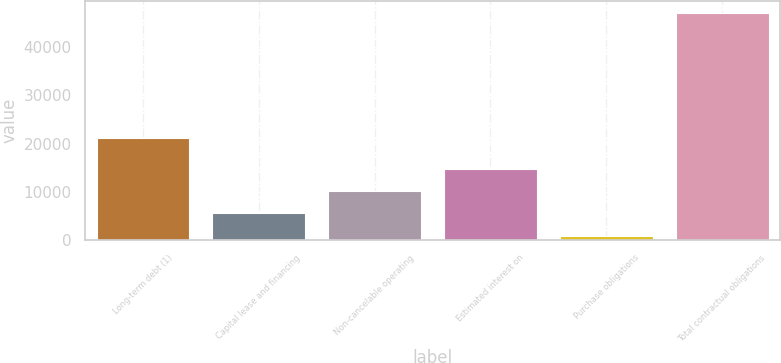<chart> <loc_0><loc_0><loc_500><loc_500><bar_chart><fcel>Long-term debt (1)<fcel>Capital lease and financing<fcel>Non-cancelable operating<fcel>Estimated interest on<fcel>Purchase obligations<fcel>Total contractual obligations<nl><fcel>21259<fcel>5544.6<fcel>10164.2<fcel>14783.8<fcel>925<fcel>47121<nl></chart> 